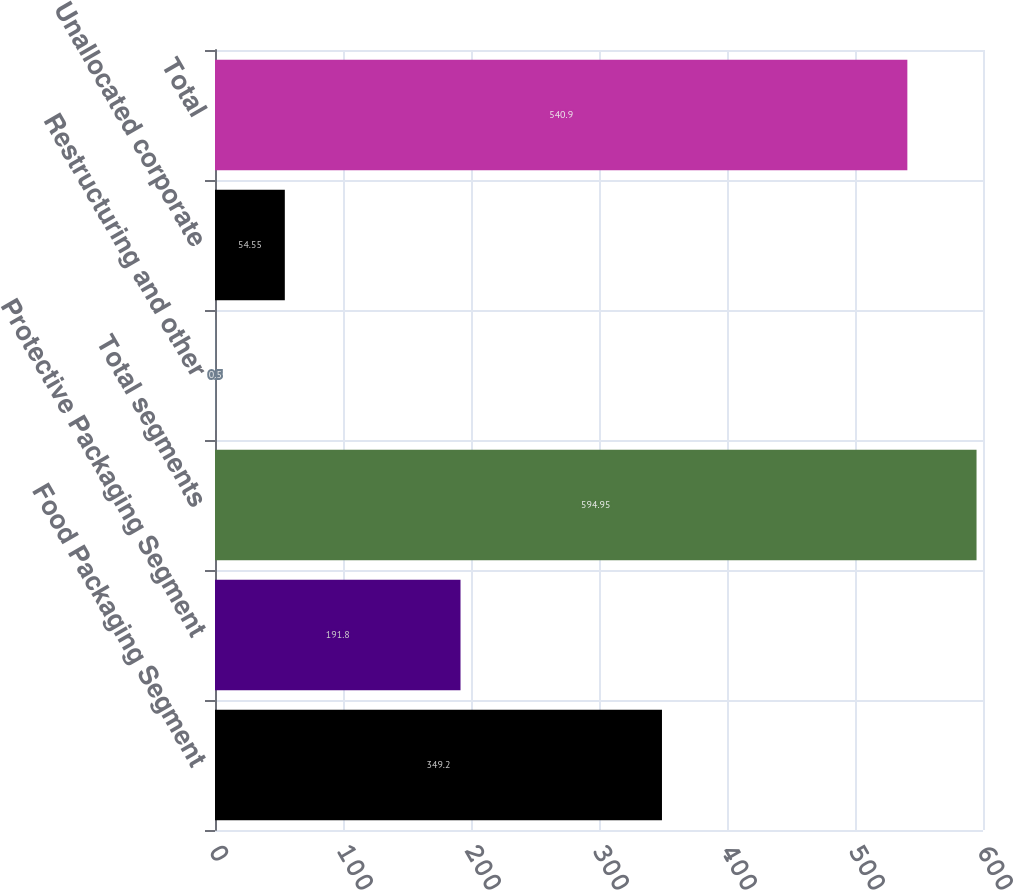<chart> <loc_0><loc_0><loc_500><loc_500><bar_chart><fcel>Food Packaging Segment<fcel>Protective Packaging Segment<fcel>Total segments<fcel>Restructuring and other<fcel>Unallocated corporate<fcel>Total<nl><fcel>349.2<fcel>191.8<fcel>594.95<fcel>0.5<fcel>54.55<fcel>540.9<nl></chart> 